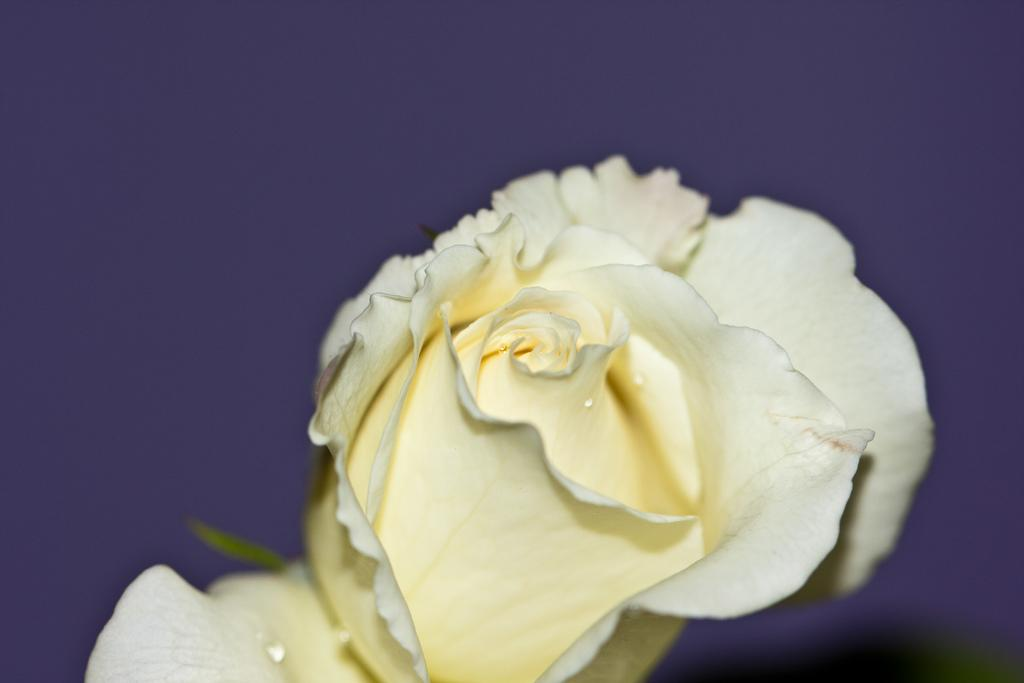What is the main subject of the image? There is a flower in the image. What color is the background of the image? The background of the image is purple. What type of transport can be seen in the image? There is no transport visible in the image; it features a flower and a purple background. What is the weather like in the image? The provided facts do not mention any weather-related elements, such as fog or a zephyr. 